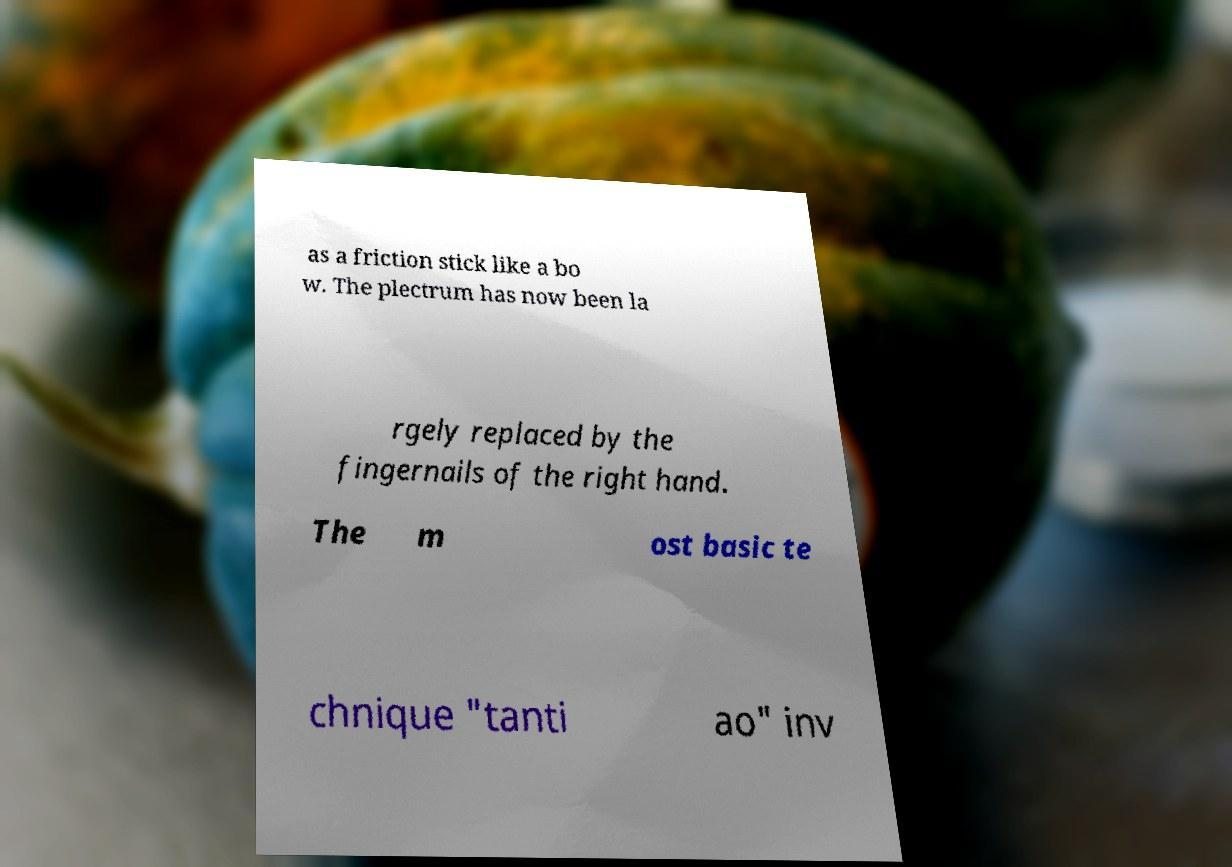Please identify and transcribe the text found in this image. as a friction stick like a bo w. The plectrum has now been la rgely replaced by the fingernails of the right hand. The m ost basic te chnique "tanti ao" inv 